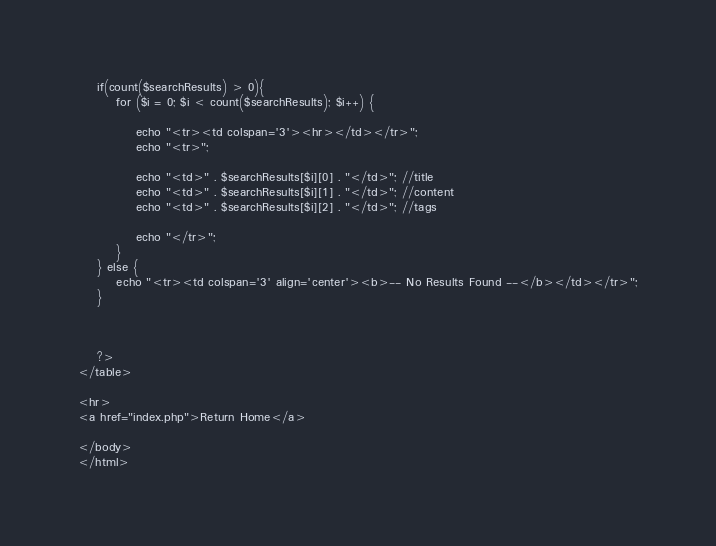<code> <loc_0><loc_0><loc_500><loc_500><_PHP_>
    if(count($searchResults) > 0){
        for ($i = 0; $i < count($searchResults); $i++) {

            echo "<tr><td colspan='3'><hr></td></tr>";
            echo "<tr>";

            echo "<td>" . $searchResults[$i][0] . "</td>"; //title
            echo "<td>" . $searchResults[$i][1] . "</td>"; //content
            echo "<td>" . $searchResults[$i][2] . "</td>"; //tags

            echo "</tr>";
        }
    } else {
        echo "<tr><td colspan='3' align='center'><b>-- No Results Found --</b></td></tr>";
    }



    ?>
</table>

<hr>
<a href="index.php">Return Home</a>

</body>
</html></code> 